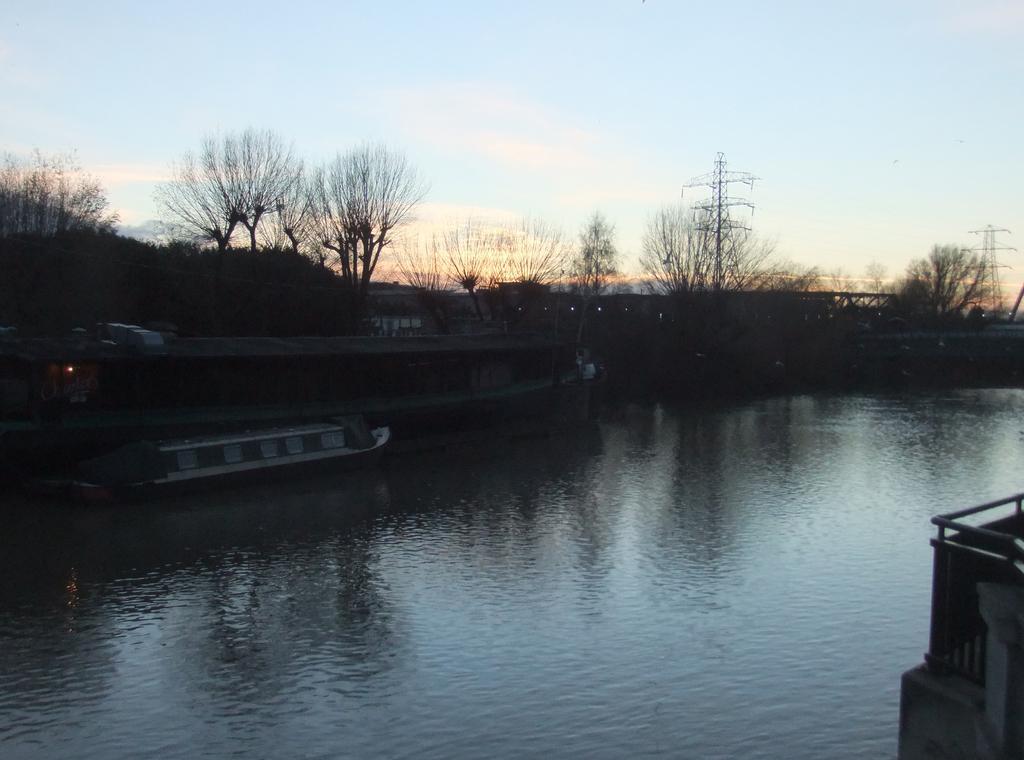How would you summarize this image in a sentence or two? In this image we can see the wall, water, boat floating on the water, trees, towers and the sky in the background. 